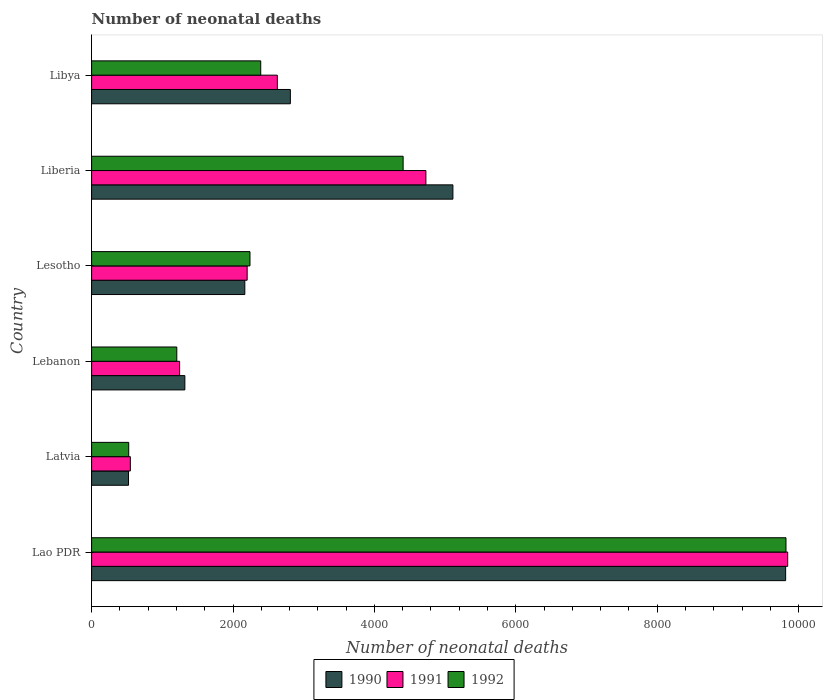How many groups of bars are there?
Your answer should be compact. 6. How many bars are there on the 5th tick from the top?
Your answer should be very brief. 3. How many bars are there on the 2nd tick from the bottom?
Make the answer very short. 3. What is the label of the 4th group of bars from the top?
Keep it short and to the point. Lebanon. In how many cases, is the number of bars for a given country not equal to the number of legend labels?
Offer a terse response. 0. What is the number of neonatal deaths in in 1992 in Libya?
Your answer should be compact. 2392. Across all countries, what is the maximum number of neonatal deaths in in 1991?
Ensure brevity in your answer.  9845. Across all countries, what is the minimum number of neonatal deaths in in 1991?
Offer a very short reply. 548. In which country was the number of neonatal deaths in in 1992 maximum?
Provide a short and direct response. Lao PDR. In which country was the number of neonatal deaths in in 1992 minimum?
Ensure brevity in your answer.  Latvia. What is the total number of neonatal deaths in in 1991 in the graph?
Offer a very short reply. 2.12e+04. What is the difference between the number of neonatal deaths in in 1990 in Liberia and that in Libya?
Offer a very short reply. 2299. What is the difference between the number of neonatal deaths in in 1991 in Liberia and the number of neonatal deaths in in 1992 in Latvia?
Your answer should be very brief. 4203. What is the average number of neonatal deaths in in 1992 per country?
Provide a short and direct response. 3431.5. What is the difference between the number of neonatal deaths in in 1991 and number of neonatal deaths in in 1990 in Lao PDR?
Your answer should be compact. 29. What is the ratio of the number of neonatal deaths in in 1990 in Latvia to that in Lebanon?
Provide a short and direct response. 0.4. Is the number of neonatal deaths in in 1990 in Liberia less than that in Libya?
Make the answer very short. No. Is the difference between the number of neonatal deaths in in 1991 in Lao PDR and Lebanon greater than the difference between the number of neonatal deaths in in 1990 in Lao PDR and Lebanon?
Ensure brevity in your answer.  Yes. What is the difference between the highest and the second highest number of neonatal deaths in in 1991?
Give a very brief answer. 5117. What is the difference between the highest and the lowest number of neonatal deaths in in 1990?
Make the answer very short. 9294. In how many countries, is the number of neonatal deaths in in 1991 greater than the average number of neonatal deaths in in 1991 taken over all countries?
Offer a very short reply. 2. What does the 3rd bar from the top in Lao PDR represents?
Make the answer very short. 1990. What does the 1st bar from the bottom in Libya represents?
Your response must be concise. 1990. What is the difference between two consecutive major ticks on the X-axis?
Your response must be concise. 2000. How many legend labels are there?
Give a very brief answer. 3. How are the legend labels stacked?
Your answer should be very brief. Horizontal. What is the title of the graph?
Ensure brevity in your answer.  Number of neonatal deaths. Does "1981" appear as one of the legend labels in the graph?
Make the answer very short. No. What is the label or title of the X-axis?
Give a very brief answer. Number of neonatal deaths. What is the Number of neonatal deaths in 1990 in Lao PDR?
Your response must be concise. 9816. What is the Number of neonatal deaths in 1991 in Lao PDR?
Make the answer very short. 9845. What is the Number of neonatal deaths of 1992 in Lao PDR?
Offer a very short reply. 9821. What is the Number of neonatal deaths in 1990 in Latvia?
Provide a short and direct response. 522. What is the Number of neonatal deaths of 1991 in Latvia?
Provide a short and direct response. 548. What is the Number of neonatal deaths in 1992 in Latvia?
Offer a terse response. 525. What is the Number of neonatal deaths in 1990 in Lebanon?
Offer a very short reply. 1319. What is the Number of neonatal deaths in 1991 in Lebanon?
Keep it short and to the point. 1245. What is the Number of neonatal deaths of 1992 in Lebanon?
Your response must be concise. 1205. What is the Number of neonatal deaths in 1990 in Lesotho?
Ensure brevity in your answer.  2167. What is the Number of neonatal deaths in 1991 in Lesotho?
Keep it short and to the point. 2200. What is the Number of neonatal deaths in 1992 in Lesotho?
Give a very brief answer. 2240. What is the Number of neonatal deaths of 1990 in Liberia?
Your answer should be very brief. 5110. What is the Number of neonatal deaths in 1991 in Liberia?
Give a very brief answer. 4728. What is the Number of neonatal deaths of 1992 in Liberia?
Your response must be concise. 4406. What is the Number of neonatal deaths of 1990 in Libya?
Ensure brevity in your answer.  2811. What is the Number of neonatal deaths in 1991 in Libya?
Your answer should be very brief. 2627. What is the Number of neonatal deaths of 1992 in Libya?
Offer a very short reply. 2392. Across all countries, what is the maximum Number of neonatal deaths of 1990?
Provide a short and direct response. 9816. Across all countries, what is the maximum Number of neonatal deaths in 1991?
Keep it short and to the point. 9845. Across all countries, what is the maximum Number of neonatal deaths in 1992?
Keep it short and to the point. 9821. Across all countries, what is the minimum Number of neonatal deaths in 1990?
Ensure brevity in your answer.  522. Across all countries, what is the minimum Number of neonatal deaths of 1991?
Offer a terse response. 548. Across all countries, what is the minimum Number of neonatal deaths of 1992?
Your response must be concise. 525. What is the total Number of neonatal deaths in 1990 in the graph?
Make the answer very short. 2.17e+04. What is the total Number of neonatal deaths in 1991 in the graph?
Provide a short and direct response. 2.12e+04. What is the total Number of neonatal deaths of 1992 in the graph?
Make the answer very short. 2.06e+04. What is the difference between the Number of neonatal deaths of 1990 in Lao PDR and that in Latvia?
Your answer should be compact. 9294. What is the difference between the Number of neonatal deaths in 1991 in Lao PDR and that in Latvia?
Provide a succinct answer. 9297. What is the difference between the Number of neonatal deaths in 1992 in Lao PDR and that in Latvia?
Provide a short and direct response. 9296. What is the difference between the Number of neonatal deaths of 1990 in Lao PDR and that in Lebanon?
Your response must be concise. 8497. What is the difference between the Number of neonatal deaths of 1991 in Lao PDR and that in Lebanon?
Offer a terse response. 8600. What is the difference between the Number of neonatal deaths of 1992 in Lao PDR and that in Lebanon?
Provide a short and direct response. 8616. What is the difference between the Number of neonatal deaths of 1990 in Lao PDR and that in Lesotho?
Keep it short and to the point. 7649. What is the difference between the Number of neonatal deaths in 1991 in Lao PDR and that in Lesotho?
Provide a short and direct response. 7645. What is the difference between the Number of neonatal deaths in 1992 in Lao PDR and that in Lesotho?
Your answer should be very brief. 7581. What is the difference between the Number of neonatal deaths of 1990 in Lao PDR and that in Liberia?
Your answer should be compact. 4706. What is the difference between the Number of neonatal deaths of 1991 in Lao PDR and that in Liberia?
Provide a short and direct response. 5117. What is the difference between the Number of neonatal deaths in 1992 in Lao PDR and that in Liberia?
Ensure brevity in your answer.  5415. What is the difference between the Number of neonatal deaths of 1990 in Lao PDR and that in Libya?
Offer a very short reply. 7005. What is the difference between the Number of neonatal deaths of 1991 in Lao PDR and that in Libya?
Provide a short and direct response. 7218. What is the difference between the Number of neonatal deaths in 1992 in Lao PDR and that in Libya?
Provide a succinct answer. 7429. What is the difference between the Number of neonatal deaths of 1990 in Latvia and that in Lebanon?
Your response must be concise. -797. What is the difference between the Number of neonatal deaths of 1991 in Latvia and that in Lebanon?
Keep it short and to the point. -697. What is the difference between the Number of neonatal deaths in 1992 in Latvia and that in Lebanon?
Your answer should be very brief. -680. What is the difference between the Number of neonatal deaths of 1990 in Latvia and that in Lesotho?
Keep it short and to the point. -1645. What is the difference between the Number of neonatal deaths of 1991 in Latvia and that in Lesotho?
Offer a terse response. -1652. What is the difference between the Number of neonatal deaths in 1992 in Latvia and that in Lesotho?
Keep it short and to the point. -1715. What is the difference between the Number of neonatal deaths of 1990 in Latvia and that in Liberia?
Your answer should be compact. -4588. What is the difference between the Number of neonatal deaths in 1991 in Latvia and that in Liberia?
Keep it short and to the point. -4180. What is the difference between the Number of neonatal deaths of 1992 in Latvia and that in Liberia?
Offer a terse response. -3881. What is the difference between the Number of neonatal deaths in 1990 in Latvia and that in Libya?
Keep it short and to the point. -2289. What is the difference between the Number of neonatal deaths in 1991 in Latvia and that in Libya?
Provide a short and direct response. -2079. What is the difference between the Number of neonatal deaths in 1992 in Latvia and that in Libya?
Your answer should be compact. -1867. What is the difference between the Number of neonatal deaths in 1990 in Lebanon and that in Lesotho?
Make the answer very short. -848. What is the difference between the Number of neonatal deaths of 1991 in Lebanon and that in Lesotho?
Offer a very short reply. -955. What is the difference between the Number of neonatal deaths of 1992 in Lebanon and that in Lesotho?
Offer a very short reply. -1035. What is the difference between the Number of neonatal deaths of 1990 in Lebanon and that in Liberia?
Your response must be concise. -3791. What is the difference between the Number of neonatal deaths of 1991 in Lebanon and that in Liberia?
Ensure brevity in your answer.  -3483. What is the difference between the Number of neonatal deaths in 1992 in Lebanon and that in Liberia?
Offer a very short reply. -3201. What is the difference between the Number of neonatal deaths of 1990 in Lebanon and that in Libya?
Offer a terse response. -1492. What is the difference between the Number of neonatal deaths in 1991 in Lebanon and that in Libya?
Offer a very short reply. -1382. What is the difference between the Number of neonatal deaths of 1992 in Lebanon and that in Libya?
Provide a succinct answer. -1187. What is the difference between the Number of neonatal deaths in 1990 in Lesotho and that in Liberia?
Offer a very short reply. -2943. What is the difference between the Number of neonatal deaths in 1991 in Lesotho and that in Liberia?
Provide a short and direct response. -2528. What is the difference between the Number of neonatal deaths of 1992 in Lesotho and that in Liberia?
Your response must be concise. -2166. What is the difference between the Number of neonatal deaths in 1990 in Lesotho and that in Libya?
Keep it short and to the point. -644. What is the difference between the Number of neonatal deaths of 1991 in Lesotho and that in Libya?
Your answer should be very brief. -427. What is the difference between the Number of neonatal deaths in 1992 in Lesotho and that in Libya?
Keep it short and to the point. -152. What is the difference between the Number of neonatal deaths of 1990 in Liberia and that in Libya?
Offer a terse response. 2299. What is the difference between the Number of neonatal deaths of 1991 in Liberia and that in Libya?
Your response must be concise. 2101. What is the difference between the Number of neonatal deaths in 1992 in Liberia and that in Libya?
Provide a short and direct response. 2014. What is the difference between the Number of neonatal deaths in 1990 in Lao PDR and the Number of neonatal deaths in 1991 in Latvia?
Provide a short and direct response. 9268. What is the difference between the Number of neonatal deaths of 1990 in Lao PDR and the Number of neonatal deaths of 1992 in Latvia?
Ensure brevity in your answer.  9291. What is the difference between the Number of neonatal deaths of 1991 in Lao PDR and the Number of neonatal deaths of 1992 in Latvia?
Give a very brief answer. 9320. What is the difference between the Number of neonatal deaths in 1990 in Lao PDR and the Number of neonatal deaths in 1991 in Lebanon?
Give a very brief answer. 8571. What is the difference between the Number of neonatal deaths in 1990 in Lao PDR and the Number of neonatal deaths in 1992 in Lebanon?
Provide a succinct answer. 8611. What is the difference between the Number of neonatal deaths in 1991 in Lao PDR and the Number of neonatal deaths in 1992 in Lebanon?
Your response must be concise. 8640. What is the difference between the Number of neonatal deaths of 1990 in Lao PDR and the Number of neonatal deaths of 1991 in Lesotho?
Provide a succinct answer. 7616. What is the difference between the Number of neonatal deaths in 1990 in Lao PDR and the Number of neonatal deaths in 1992 in Lesotho?
Keep it short and to the point. 7576. What is the difference between the Number of neonatal deaths of 1991 in Lao PDR and the Number of neonatal deaths of 1992 in Lesotho?
Your answer should be compact. 7605. What is the difference between the Number of neonatal deaths in 1990 in Lao PDR and the Number of neonatal deaths in 1991 in Liberia?
Offer a terse response. 5088. What is the difference between the Number of neonatal deaths of 1990 in Lao PDR and the Number of neonatal deaths of 1992 in Liberia?
Make the answer very short. 5410. What is the difference between the Number of neonatal deaths of 1991 in Lao PDR and the Number of neonatal deaths of 1992 in Liberia?
Keep it short and to the point. 5439. What is the difference between the Number of neonatal deaths in 1990 in Lao PDR and the Number of neonatal deaths in 1991 in Libya?
Give a very brief answer. 7189. What is the difference between the Number of neonatal deaths in 1990 in Lao PDR and the Number of neonatal deaths in 1992 in Libya?
Keep it short and to the point. 7424. What is the difference between the Number of neonatal deaths of 1991 in Lao PDR and the Number of neonatal deaths of 1992 in Libya?
Keep it short and to the point. 7453. What is the difference between the Number of neonatal deaths in 1990 in Latvia and the Number of neonatal deaths in 1991 in Lebanon?
Your response must be concise. -723. What is the difference between the Number of neonatal deaths in 1990 in Latvia and the Number of neonatal deaths in 1992 in Lebanon?
Keep it short and to the point. -683. What is the difference between the Number of neonatal deaths of 1991 in Latvia and the Number of neonatal deaths of 1992 in Lebanon?
Provide a succinct answer. -657. What is the difference between the Number of neonatal deaths of 1990 in Latvia and the Number of neonatal deaths of 1991 in Lesotho?
Keep it short and to the point. -1678. What is the difference between the Number of neonatal deaths in 1990 in Latvia and the Number of neonatal deaths in 1992 in Lesotho?
Make the answer very short. -1718. What is the difference between the Number of neonatal deaths in 1991 in Latvia and the Number of neonatal deaths in 1992 in Lesotho?
Offer a very short reply. -1692. What is the difference between the Number of neonatal deaths of 1990 in Latvia and the Number of neonatal deaths of 1991 in Liberia?
Give a very brief answer. -4206. What is the difference between the Number of neonatal deaths of 1990 in Latvia and the Number of neonatal deaths of 1992 in Liberia?
Ensure brevity in your answer.  -3884. What is the difference between the Number of neonatal deaths in 1991 in Latvia and the Number of neonatal deaths in 1992 in Liberia?
Provide a short and direct response. -3858. What is the difference between the Number of neonatal deaths in 1990 in Latvia and the Number of neonatal deaths in 1991 in Libya?
Provide a short and direct response. -2105. What is the difference between the Number of neonatal deaths in 1990 in Latvia and the Number of neonatal deaths in 1992 in Libya?
Offer a terse response. -1870. What is the difference between the Number of neonatal deaths of 1991 in Latvia and the Number of neonatal deaths of 1992 in Libya?
Offer a terse response. -1844. What is the difference between the Number of neonatal deaths in 1990 in Lebanon and the Number of neonatal deaths in 1991 in Lesotho?
Your answer should be very brief. -881. What is the difference between the Number of neonatal deaths in 1990 in Lebanon and the Number of neonatal deaths in 1992 in Lesotho?
Provide a succinct answer. -921. What is the difference between the Number of neonatal deaths in 1991 in Lebanon and the Number of neonatal deaths in 1992 in Lesotho?
Offer a very short reply. -995. What is the difference between the Number of neonatal deaths in 1990 in Lebanon and the Number of neonatal deaths in 1991 in Liberia?
Your response must be concise. -3409. What is the difference between the Number of neonatal deaths of 1990 in Lebanon and the Number of neonatal deaths of 1992 in Liberia?
Your answer should be compact. -3087. What is the difference between the Number of neonatal deaths in 1991 in Lebanon and the Number of neonatal deaths in 1992 in Liberia?
Your response must be concise. -3161. What is the difference between the Number of neonatal deaths in 1990 in Lebanon and the Number of neonatal deaths in 1991 in Libya?
Make the answer very short. -1308. What is the difference between the Number of neonatal deaths in 1990 in Lebanon and the Number of neonatal deaths in 1992 in Libya?
Your response must be concise. -1073. What is the difference between the Number of neonatal deaths in 1991 in Lebanon and the Number of neonatal deaths in 1992 in Libya?
Offer a very short reply. -1147. What is the difference between the Number of neonatal deaths in 1990 in Lesotho and the Number of neonatal deaths in 1991 in Liberia?
Your answer should be compact. -2561. What is the difference between the Number of neonatal deaths of 1990 in Lesotho and the Number of neonatal deaths of 1992 in Liberia?
Provide a succinct answer. -2239. What is the difference between the Number of neonatal deaths of 1991 in Lesotho and the Number of neonatal deaths of 1992 in Liberia?
Offer a terse response. -2206. What is the difference between the Number of neonatal deaths in 1990 in Lesotho and the Number of neonatal deaths in 1991 in Libya?
Your answer should be compact. -460. What is the difference between the Number of neonatal deaths of 1990 in Lesotho and the Number of neonatal deaths of 1992 in Libya?
Ensure brevity in your answer.  -225. What is the difference between the Number of neonatal deaths in 1991 in Lesotho and the Number of neonatal deaths in 1992 in Libya?
Your answer should be compact. -192. What is the difference between the Number of neonatal deaths of 1990 in Liberia and the Number of neonatal deaths of 1991 in Libya?
Ensure brevity in your answer.  2483. What is the difference between the Number of neonatal deaths in 1990 in Liberia and the Number of neonatal deaths in 1992 in Libya?
Provide a succinct answer. 2718. What is the difference between the Number of neonatal deaths in 1991 in Liberia and the Number of neonatal deaths in 1992 in Libya?
Give a very brief answer. 2336. What is the average Number of neonatal deaths in 1990 per country?
Provide a succinct answer. 3624.17. What is the average Number of neonatal deaths in 1991 per country?
Give a very brief answer. 3532.17. What is the average Number of neonatal deaths of 1992 per country?
Provide a short and direct response. 3431.5. What is the difference between the Number of neonatal deaths of 1990 and Number of neonatal deaths of 1991 in Lao PDR?
Keep it short and to the point. -29. What is the difference between the Number of neonatal deaths of 1991 and Number of neonatal deaths of 1992 in Lao PDR?
Give a very brief answer. 24. What is the difference between the Number of neonatal deaths of 1990 and Number of neonatal deaths of 1991 in Latvia?
Give a very brief answer. -26. What is the difference between the Number of neonatal deaths of 1991 and Number of neonatal deaths of 1992 in Latvia?
Provide a succinct answer. 23. What is the difference between the Number of neonatal deaths of 1990 and Number of neonatal deaths of 1991 in Lebanon?
Keep it short and to the point. 74. What is the difference between the Number of neonatal deaths of 1990 and Number of neonatal deaths of 1992 in Lebanon?
Give a very brief answer. 114. What is the difference between the Number of neonatal deaths of 1990 and Number of neonatal deaths of 1991 in Lesotho?
Your answer should be very brief. -33. What is the difference between the Number of neonatal deaths in 1990 and Number of neonatal deaths in 1992 in Lesotho?
Keep it short and to the point. -73. What is the difference between the Number of neonatal deaths in 1991 and Number of neonatal deaths in 1992 in Lesotho?
Keep it short and to the point. -40. What is the difference between the Number of neonatal deaths in 1990 and Number of neonatal deaths in 1991 in Liberia?
Provide a short and direct response. 382. What is the difference between the Number of neonatal deaths of 1990 and Number of neonatal deaths of 1992 in Liberia?
Your response must be concise. 704. What is the difference between the Number of neonatal deaths of 1991 and Number of neonatal deaths of 1992 in Liberia?
Your response must be concise. 322. What is the difference between the Number of neonatal deaths in 1990 and Number of neonatal deaths in 1991 in Libya?
Offer a terse response. 184. What is the difference between the Number of neonatal deaths in 1990 and Number of neonatal deaths in 1992 in Libya?
Your response must be concise. 419. What is the difference between the Number of neonatal deaths of 1991 and Number of neonatal deaths of 1992 in Libya?
Your response must be concise. 235. What is the ratio of the Number of neonatal deaths of 1990 in Lao PDR to that in Latvia?
Offer a terse response. 18.8. What is the ratio of the Number of neonatal deaths in 1991 in Lao PDR to that in Latvia?
Your answer should be very brief. 17.97. What is the ratio of the Number of neonatal deaths in 1992 in Lao PDR to that in Latvia?
Ensure brevity in your answer.  18.71. What is the ratio of the Number of neonatal deaths in 1990 in Lao PDR to that in Lebanon?
Ensure brevity in your answer.  7.44. What is the ratio of the Number of neonatal deaths of 1991 in Lao PDR to that in Lebanon?
Give a very brief answer. 7.91. What is the ratio of the Number of neonatal deaths in 1992 in Lao PDR to that in Lebanon?
Give a very brief answer. 8.15. What is the ratio of the Number of neonatal deaths of 1990 in Lao PDR to that in Lesotho?
Offer a terse response. 4.53. What is the ratio of the Number of neonatal deaths in 1991 in Lao PDR to that in Lesotho?
Make the answer very short. 4.47. What is the ratio of the Number of neonatal deaths of 1992 in Lao PDR to that in Lesotho?
Ensure brevity in your answer.  4.38. What is the ratio of the Number of neonatal deaths of 1990 in Lao PDR to that in Liberia?
Give a very brief answer. 1.92. What is the ratio of the Number of neonatal deaths in 1991 in Lao PDR to that in Liberia?
Your response must be concise. 2.08. What is the ratio of the Number of neonatal deaths of 1992 in Lao PDR to that in Liberia?
Make the answer very short. 2.23. What is the ratio of the Number of neonatal deaths in 1990 in Lao PDR to that in Libya?
Provide a short and direct response. 3.49. What is the ratio of the Number of neonatal deaths in 1991 in Lao PDR to that in Libya?
Provide a succinct answer. 3.75. What is the ratio of the Number of neonatal deaths in 1992 in Lao PDR to that in Libya?
Keep it short and to the point. 4.11. What is the ratio of the Number of neonatal deaths in 1990 in Latvia to that in Lebanon?
Your answer should be compact. 0.4. What is the ratio of the Number of neonatal deaths of 1991 in Latvia to that in Lebanon?
Your answer should be compact. 0.44. What is the ratio of the Number of neonatal deaths in 1992 in Latvia to that in Lebanon?
Ensure brevity in your answer.  0.44. What is the ratio of the Number of neonatal deaths of 1990 in Latvia to that in Lesotho?
Provide a short and direct response. 0.24. What is the ratio of the Number of neonatal deaths in 1991 in Latvia to that in Lesotho?
Your response must be concise. 0.25. What is the ratio of the Number of neonatal deaths of 1992 in Latvia to that in Lesotho?
Your answer should be compact. 0.23. What is the ratio of the Number of neonatal deaths in 1990 in Latvia to that in Liberia?
Ensure brevity in your answer.  0.1. What is the ratio of the Number of neonatal deaths in 1991 in Latvia to that in Liberia?
Ensure brevity in your answer.  0.12. What is the ratio of the Number of neonatal deaths in 1992 in Latvia to that in Liberia?
Provide a succinct answer. 0.12. What is the ratio of the Number of neonatal deaths of 1990 in Latvia to that in Libya?
Make the answer very short. 0.19. What is the ratio of the Number of neonatal deaths of 1991 in Latvia to that in Libya?
Your answer should be very brief. 0.21. What is the ratio of the Number of neonatal deaths in 1992 in Latvia to that in Libya?
Offer a very short reply. 0.22. What is the ratio of the Number of neonatal deaths in 1990 in Lebanon to that in Lesotho?
Provide a succinct answer. 0.61. What is the ratio of the Number of neonatal deaths in 1991 in Lebanon to that in Lesotho?
Give a very brief answer. 0.57. What is the ratio of the Number of neonatal deaths of 1992 in Lebanon to that in Lesotho?
Make the answer very short. 0.54. What is the ratio of the Number of neonatal deaths of 1990 in Lebanon to that in Liberia?
Your response must be concise. 0.26. What is the ratio of the Number of neonatal deaths of 1991 in Lebanon to that in Liberia?
Ensure brevity in your answer.  0.26. What is the ratio of the Number of neonatal deaths of 1992 in Lebanon to that in Liberia?
Make the answer very short. 0.27. What is the ratio of the Number of neonatal deaths of 1990 in Lebanon to that in Libya?
Offer a terse response. 0.47. What is the ratio of the Number of neonatal deaths in 1991 in Lebanon to that in Libya?
Ensure brevity in your answer.  0.47. What is the ratio of the Number of neonatal deaths of 1992 in Lebanon to that in Libya?
Your answer should be very brief. 0.5. What is the ratio of the Number of neonatal deaths in 1990 in Lesotho to that in Liberia?
Keep it short and to the point. 0.42. What is the ratio of the Number of neonatal deaths of 1991 in Lesotho to that in Liberia?
Your answer should be compact. 0.47. What is the ratio of the Number of neonatal deaths of 1992 in Lesotho to that in Liberia?
Make the answer very short. 0.51. What is the ratio of the Number of neonatal deaths in 1990 in Lesotho to that in Libya?
Ensure brevity in your answer.  0.77. What is the ratio of the Number of neonatal deaths of 1991 in Lesotho to that in Libya?
Your answer should be very brief. 0.84. What is the ratio of the Number of neonatal deaths of 1992 in Lesotho to that in Libya?
Your answer should be very brief. 0.94. What is the ratio of the Number of neonatal deaths in 1990 in Liberia to that in Libya?
Your answer should be very brief. 1.82. What is the ratio of the Number of neonatal deaths in 1991 in Liberia to that in Libya?
Offer a terse response. 1.8. What is the ratio of the Number of neonatal deaths in 1992 in Liberia to that in Libya?
Keep it short and to the point. 1.84. What is the difference between the highest and the second highest Number of neonatal deaths of 1990?
Give a very brief answer. 4706. What is the difference between the highest and the second highest Number of neonatal deaths of 1991?
Ensure brevity in your answer.  5117. What is the difference between the highest and the second highest Number of neonatal deaths of 1992?
Make the answer very short. 5415. What is the difference between the highest and the lowest Number of neonatal deaths in 1990?
Your answer should be very brief. 9294. What is the difference between the highest and the lowest Number of neonatal deaths of 1991?
Your response must be concise. 9297. What is the difference between the highest and the lowest Number of neonatal deaths in 1992?
Ensure brevity in your answer.  9296. 